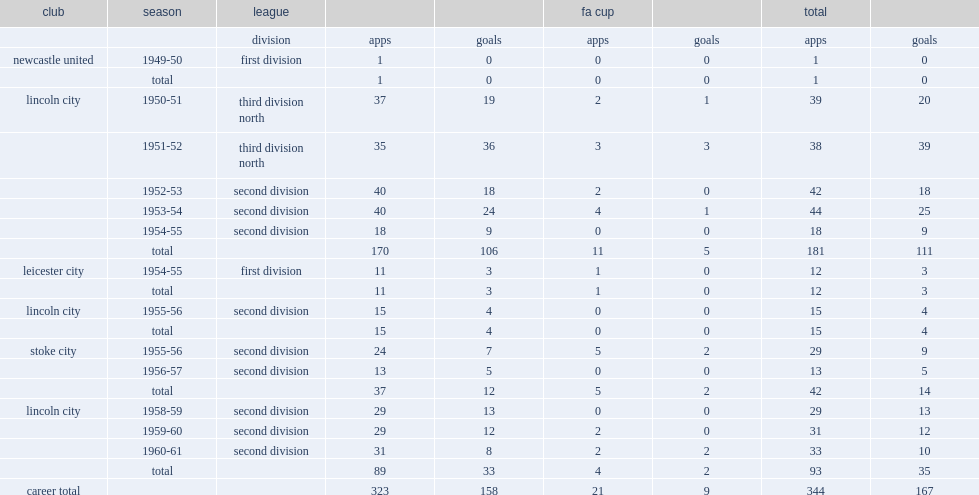How many league goals did andrew martin graver score in his career? 158.0. 